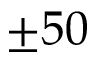<formula> <loc_0><loc_0><loc_500><loc_500>\pm 5 0</formula> 